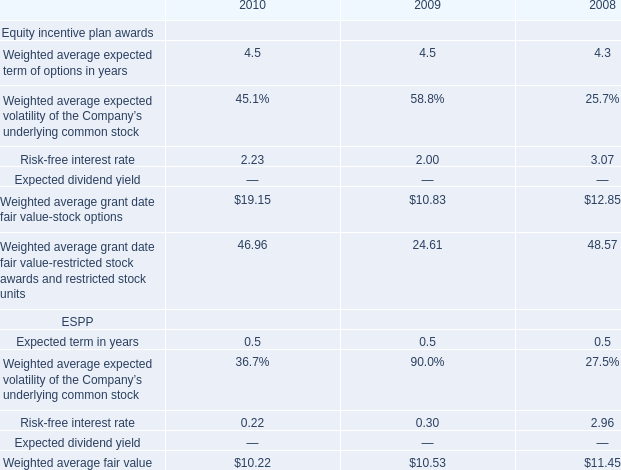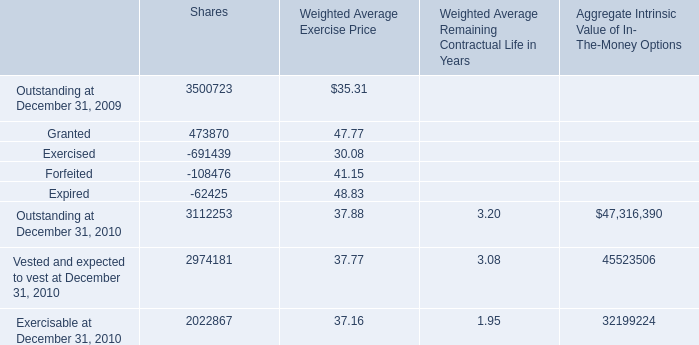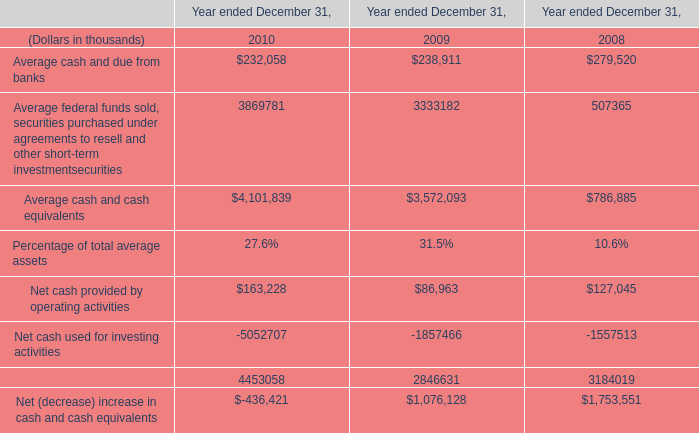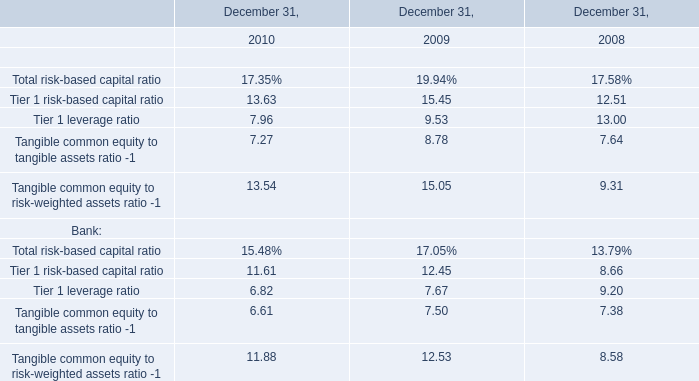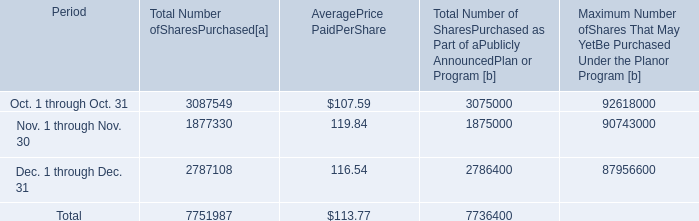What is the sum of Outstanding at December 31, 2010 of Shares, and Oct. 1 through Oct. 31 of [EMPTY].2 ? 
Computations: (3112253.0 + 3075000.0)
Answer: 6187253.0. 